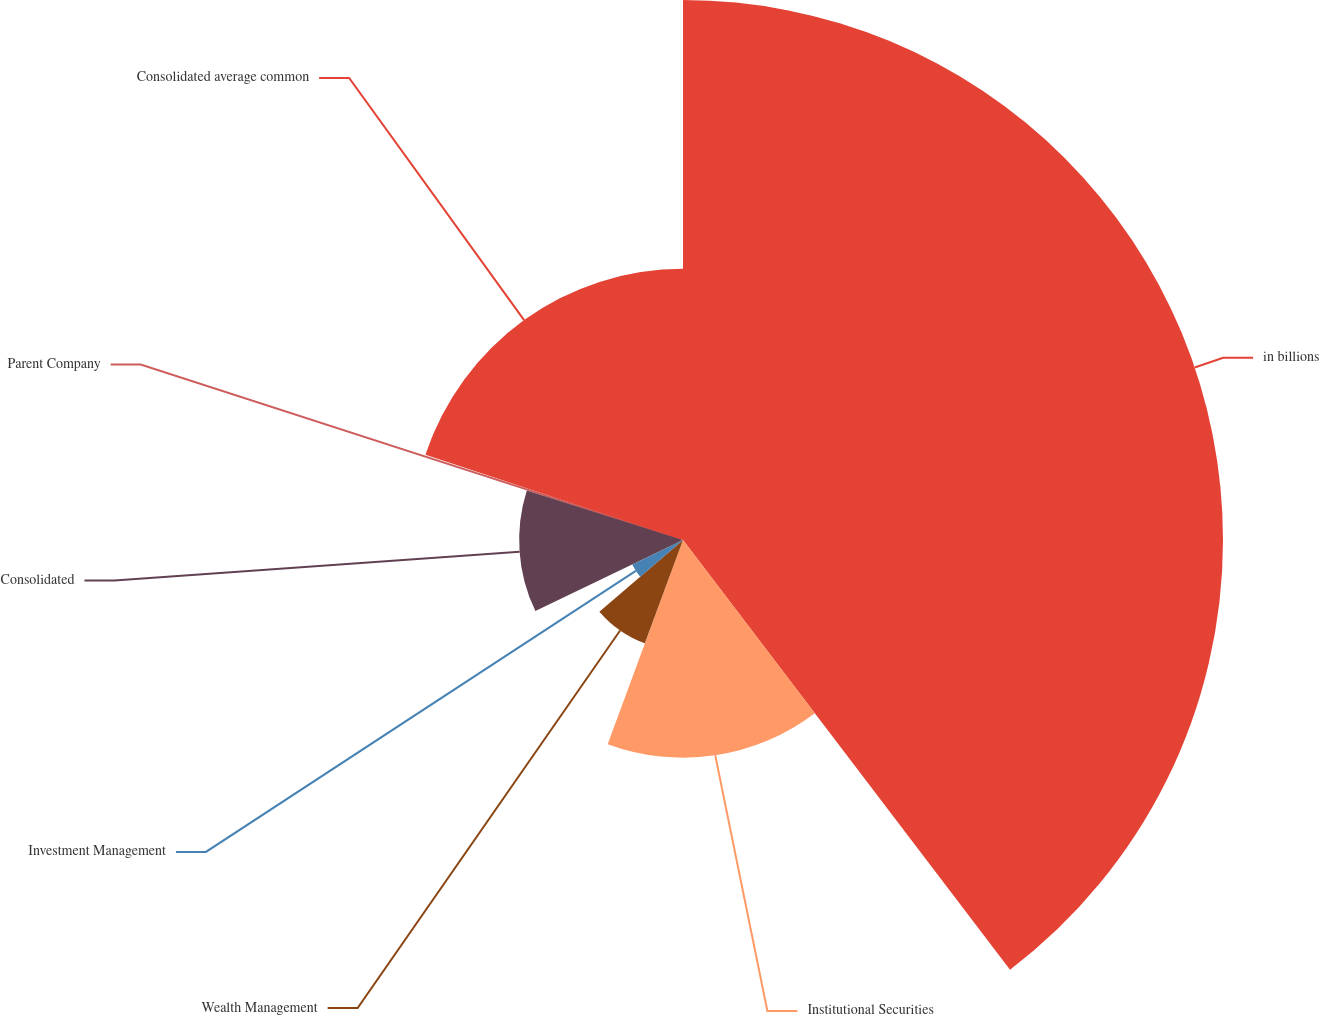Convert chart. <chart><loc_0><loc_0><loc_500><loc_500><pie_chart><fcel>in billions<fcel>Institutional Securities<fcel>Wealth Management<fcel>Investment Management<fcel>Consolidated<fcel>Parent Company<fcel>Consolidated average common<nl><fcel>39.65%<fcel>15.98%<fcel>8.09%<fcel>4.14%<fcel>12.03%<fcel>0.2%<fcel>19.92%<nl></chart> 